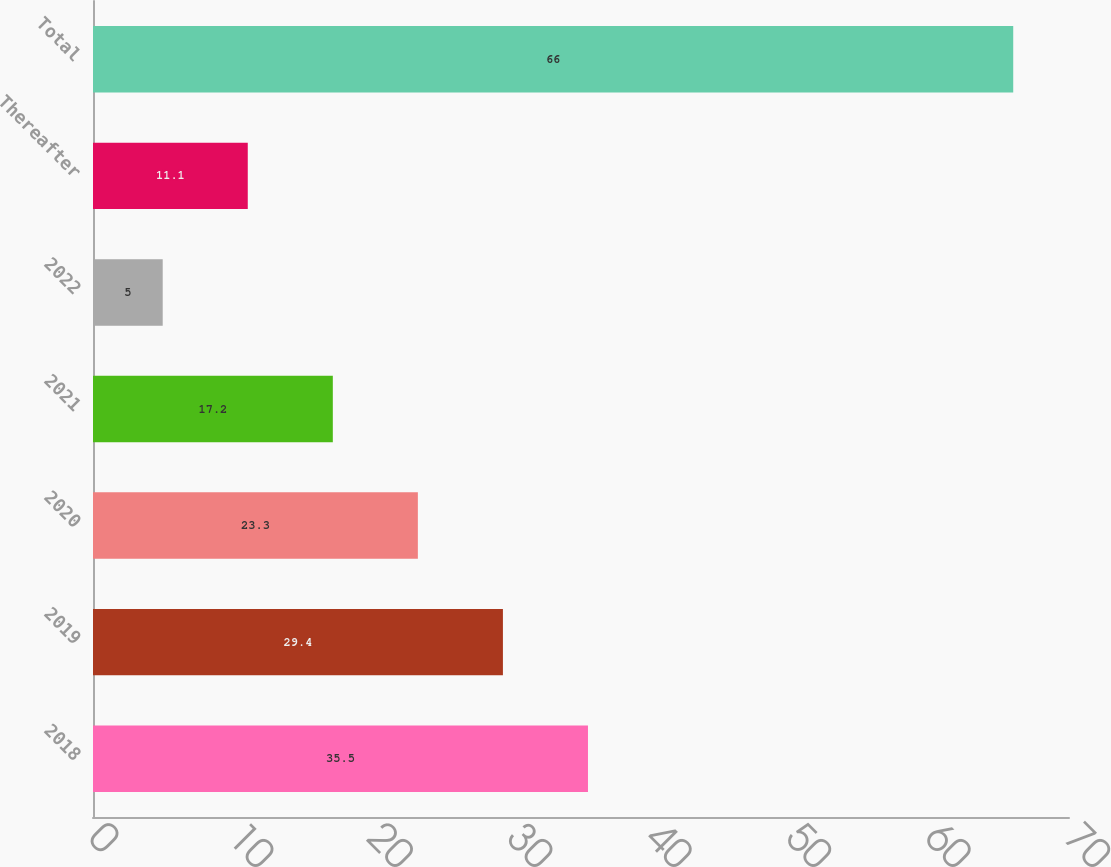<chart> <loc_0><loc_0><loc_500><loc_500><bar_chart><fcel>2018<fcel>2019<fcel>2020<fcel>2021<fcel>2022<fcel>Thereafter<fcel>Total<nl><fcel>35.5<fcel>29.4<fcel>23.3<fcel>17.2<fcel>5<fcel>11.1<fcel>66<nl></chart> 